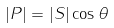<formula> <loc_0><loc_0><loc_500><loc_500>| P | = | S | \cos \theta</formula> 